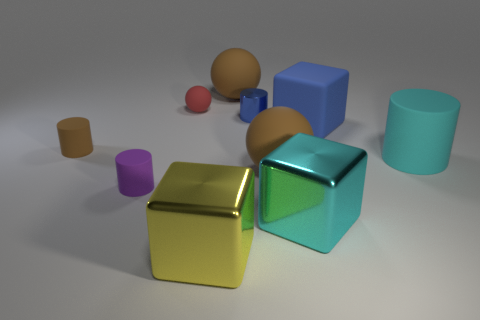Subtract all large balls. How many balls are left? 1 Subtract all blue blocks. How many blocks are left? 2 Subtract all cylinders. How many objects are left? 6 Subtract 1 cylinders. How many cylinders are left? 3 Subtract all purple cylinders. How many gray cubes are left? 0 Subtract all blue metal cylinders. Subtract all rubber spheres. How many objects are left? 6 Add 5 small blue objects. How many small blue objects are left? 6 Add 2 tiny shiny things. How many tiny shiny things exist? 3 Subtract 0 red blocks. How many objects are left? 10 Subtract all blue blocks. Subtract all yellow balls. How many blocks are left? 2 